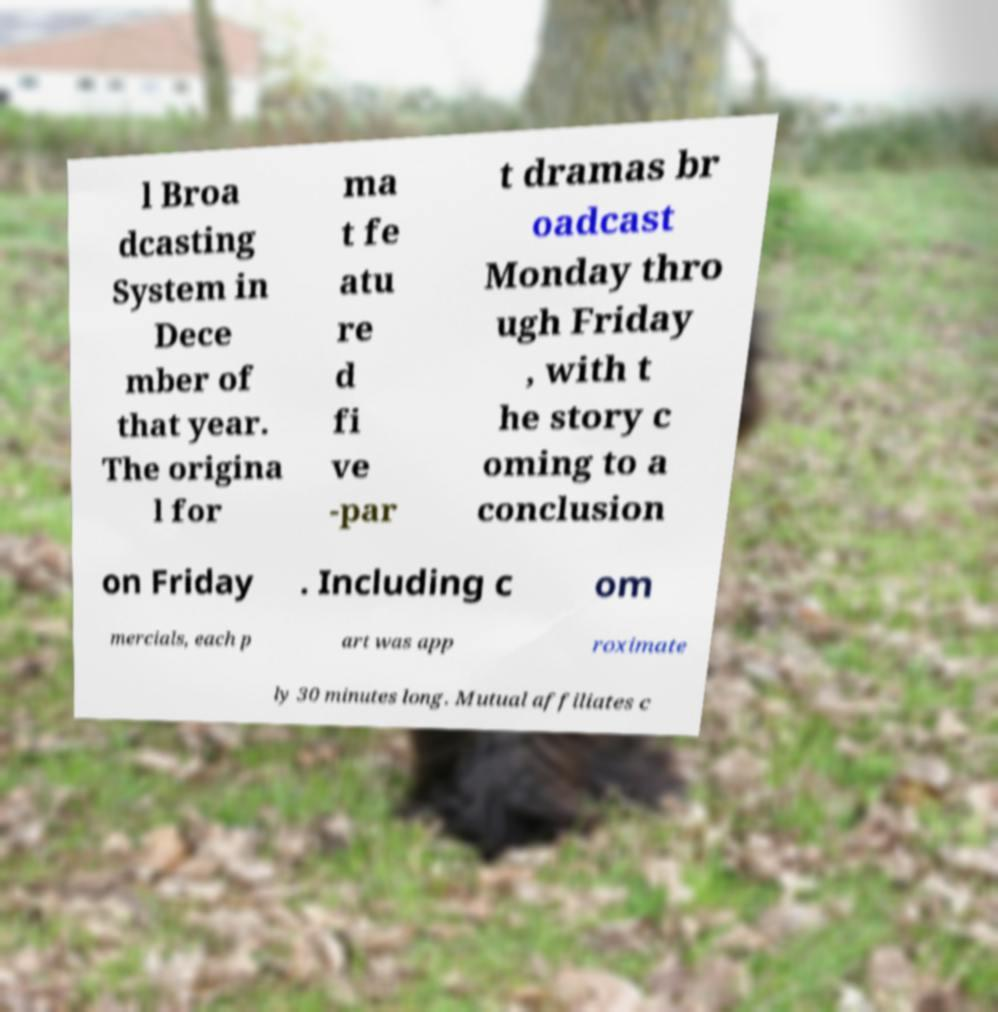Please identify and transcribe the text found in this image. l Broa dcasting System in Dece mber of that year. The origina l for ma t fe atu re d fi ve -par t dramas br oadcast Monday thro ugh Friday , with t he story c oming to a conclusion on Friday . Including c om mercials, each p art was app roximate ly 30 minutes long. Mutual affiliates c 